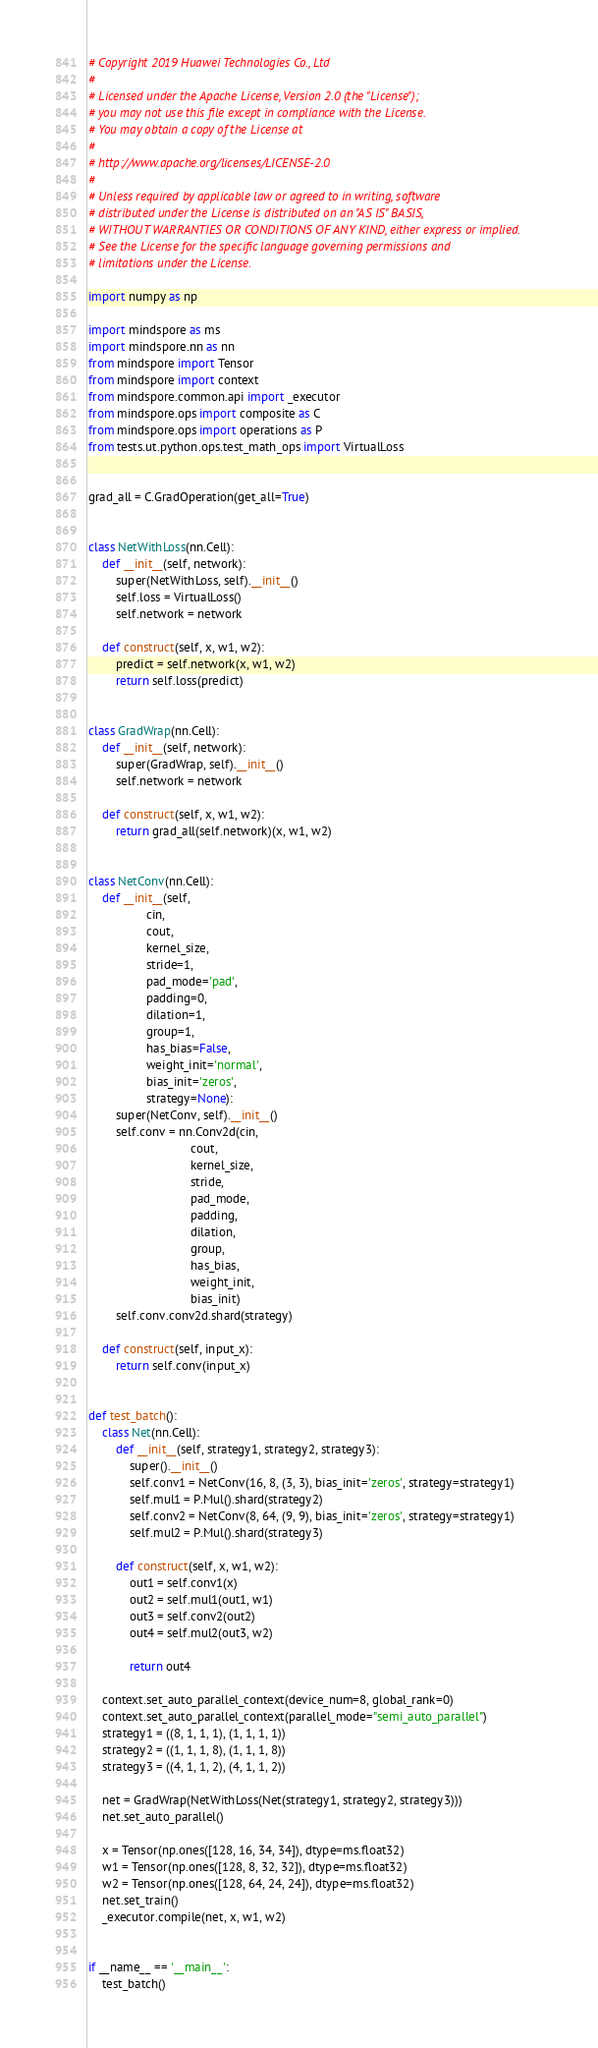<code> <loc_0><loc_0><loc_500><loc_500><_Python_># Copyright 2019 Huawei Technologies Co., Ltd
#
# Licensed under the Apache License, Version 2.0 (the "License");
# you may not use this file except in compliance with the License.
# You may obtain a copy of the License at
#
# http://www.apache.org/licenses/LICENSE-2.0
#
# Unless required by applicable law or agreed to in writing, software
# distributed under the License is distributed on an "AS IS" BASIS,
# WITHOUT WARRANTIES OR CONDITIONS OF ANY KIND, either express or implied.
# See the License for the specific language governing permissions and
# limitations under the License.

import numpy as np

import mindspore as ms
import mindspore.nn as nn
from mindspore import Tensor
from mindspore import context
from mindspore.common.api import _executor
from mindspore.ops import composite as C
from mindspore.ops import operations as P
from tests.ut.python.ops.test_math_ops import VirtualLoss


grad_all = C.GradOperation(get_all=True)


class NetWithLoss(nn.Cell):
    def __init__(self, network):
        super(NetWithLoss, self).__init__()
        self.loss = VirtualLoss()
        self.network = network

    def construct(self, x, w1, w2):
        predict = self.network(x, w1, w2)
        return self.loss(predict)


class GradWrap(nn.Cell):
    def __init__(self, network):
        super(GradWrap, self).__init__()
        self.network = network

    def construct(self, x, w1, w2):
        return grad_all(self.network)(x, w1, w2)


class NetConv(nn.Cell):
    def __init__(self,
                 cin,
                 cout,
                 kernel_size,
                 stride=1,
                 pad_mode='pad',
                 padding=0,
                 dilation=1,
                 group=1,
                 has_bias=False,
                 weight_init='normal',
                 bias_init='zeros',
                 strategy=None):
        super(NetConv, self).__init__()
        self.conv = nn.Conv2d(cin,
                              cout,
                              kernel_size,
                              stride,
                              pad_mode,
                              padding,
                              dilation,
                              group,
                              has_bias,
                              weight_init,
                              bias_init)
        self.conv.conv2d.shard(strategy)

    def construct(self, input_x):
        return self.conv(input_x)


def test_batch():
    class Net(nn.Cell):
        def __init__(self, strategy1, strategy2, strategy3):
            super().__init__()
            self.conv1 = NetConv(16, 8, (3, 3), bias_init='zeros', strategy=strategy1)
            self.mul1 = P.Mul().shard(strategy2)
            self.conv2 = NetConv(8, 64, (9, 9), bias_init='zeros', strategy=strategy1)
            self.mul2 = P.Mul().shard(strategy3)

        def construct(self, x, w1, w2):
            out1 = self.conv1(x)
            out2 = self.mul1(out1, w1)
            out3 = self.conv2(out2)
            out4 = self.mul2(out3, w2)

            return out4

    context.set_auto_parallel_context(device_num=8, global_rank=0)
    context.set_auto_parallel_context(parallel_mode="semi_auto_parallel")
    strategy1 = ((8, 1, 1, 1), (1, 1, 1, 1))
    strategy2 = ((1, 1, 1, 8), (1, 1, 1, 8))
    strategy3 = ((4, 1, 1, 2), (4, 1, 1, 2))

    net = GradWrap(NetWithLoss(Net(strategy1, strategy2, strategy3)))
    net.set_auto_parallel()

    x = Tensor(np.ones([128, 16, 34, 34]), dtype=ms.float32)
    w1 = Tensor(np.ones([128, 8, 32, 32]), dtype=ms.float32)
    w2 = Tensor(np.ones([128, 64, 24, 24]), dtype=ms.float32)
    net.set_train()
    _executor.compile(net, x, w1, w2)


if __name__ == '__main__':
    test_batch()
</code> 